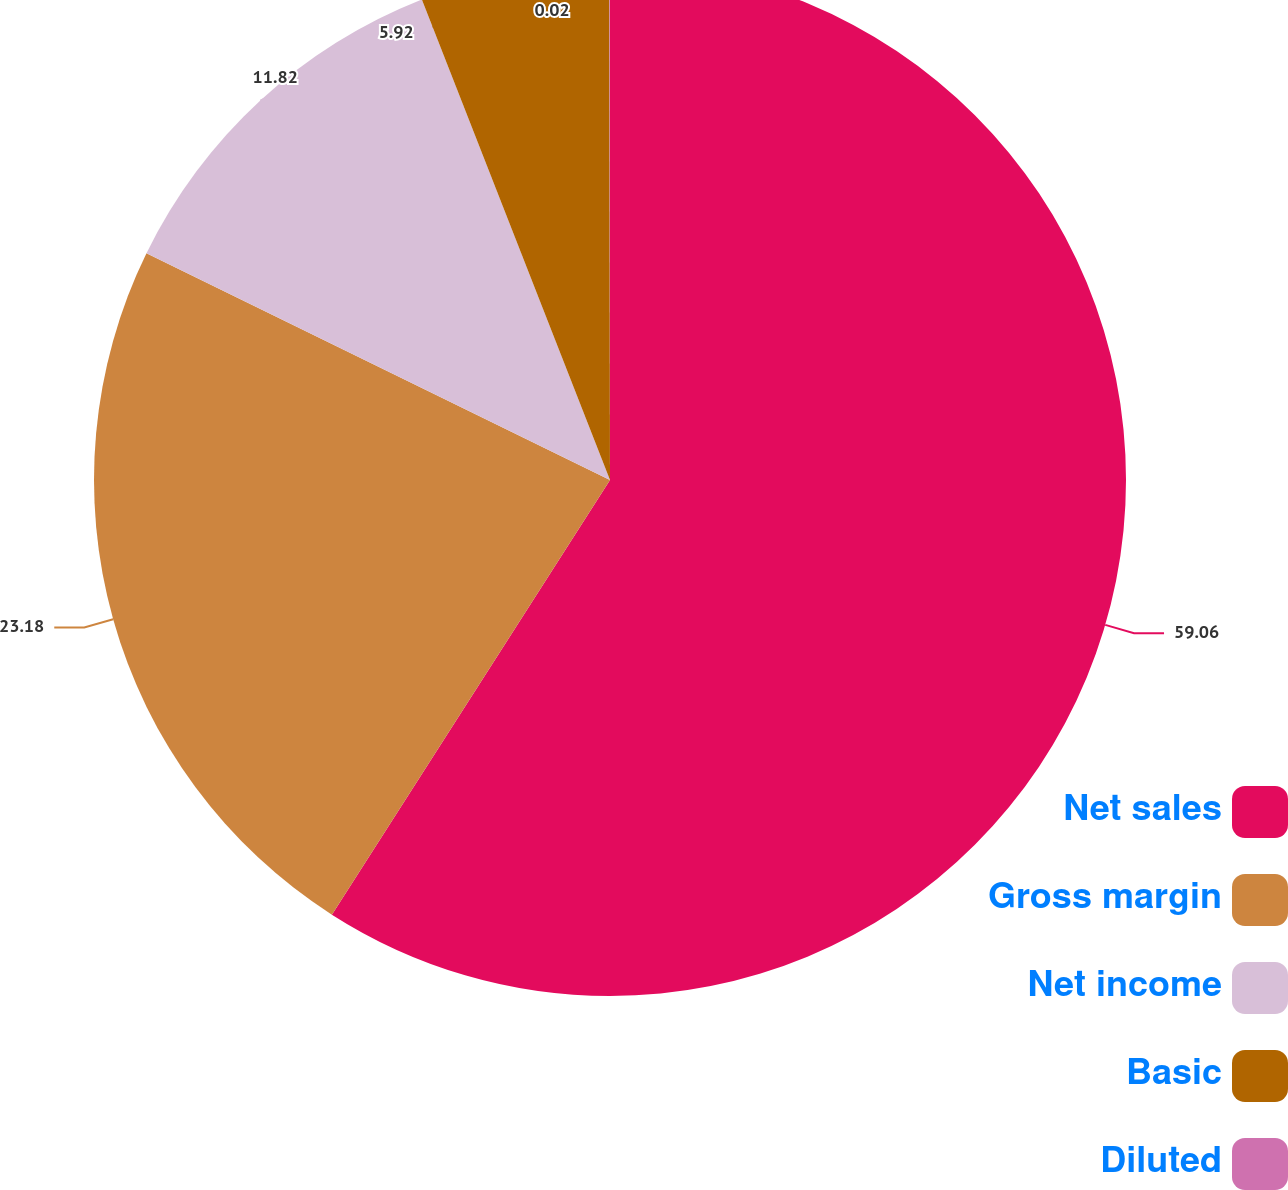<chart> <loc_0><loc_0><loc_500><loc_500><pie_chart><fcel>Net sales<fcel>Gross margin<fcel>Net income<fcel>Basic<fcel>Diluted<nl><fcel>59.06%<fcel>23.18%<fcel>11.82%<fcel>5.92%<fcel>0.02%<nl></chart> 